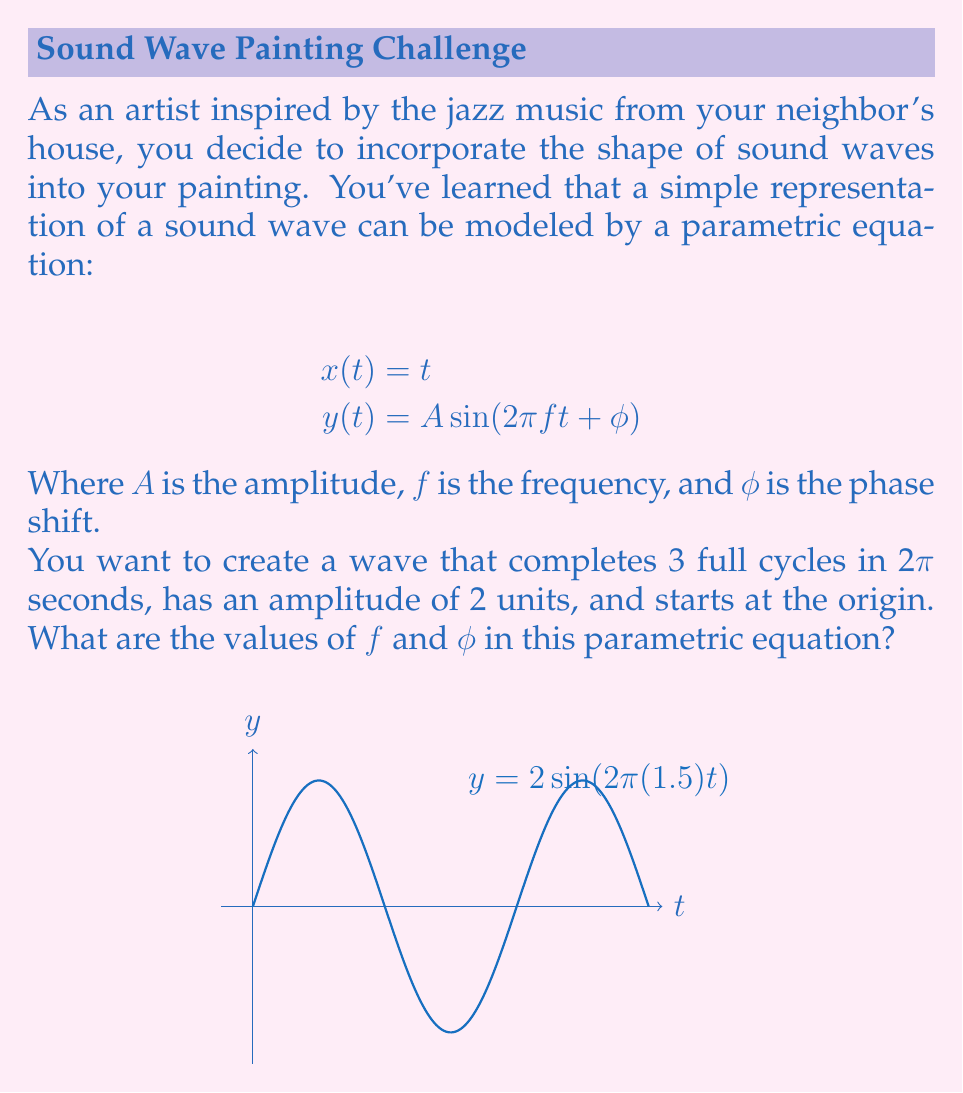Teach me how to tackle this problem. Let's approach this step-by-step:

1) First, let's consider the frequency $f$. We know that the wave completes 3 full cycles in 2π seconds. The relationship between cycles, frequency, and time is:

   $\text{number of cycles} = f \cdot \text{time}$

   $3 = f \cdot 2\pi$

   $f = \frac{3}{2\pi} = 1.5 \text{ Hz}$

2) Now for the phase shift $\phi$. We're told that the wave starts at the origin. This means when $t=0$, $y$ should also be 0. Let's use the equation:

   $y(0) = A \sin(2\pi f(0) + \phi) = 0$

   $2 \sin(0 + \phi) = 0$

   This is true when $\phi = 0$ (or any multiple of π, but we typically use the smallest possible value).

3) To verify, let's write out the full parametric equation:

   $x(t) = t$
   $y(t) = 2 \sin(2\pi(1.5)t)$

   This equation will produce a wave with amplitude 2, frequency 1.5 Hz, starting at the origin and completing 3 cycles over 2π seconds.
Answer: $f = 1.5, \phi = 0$ 